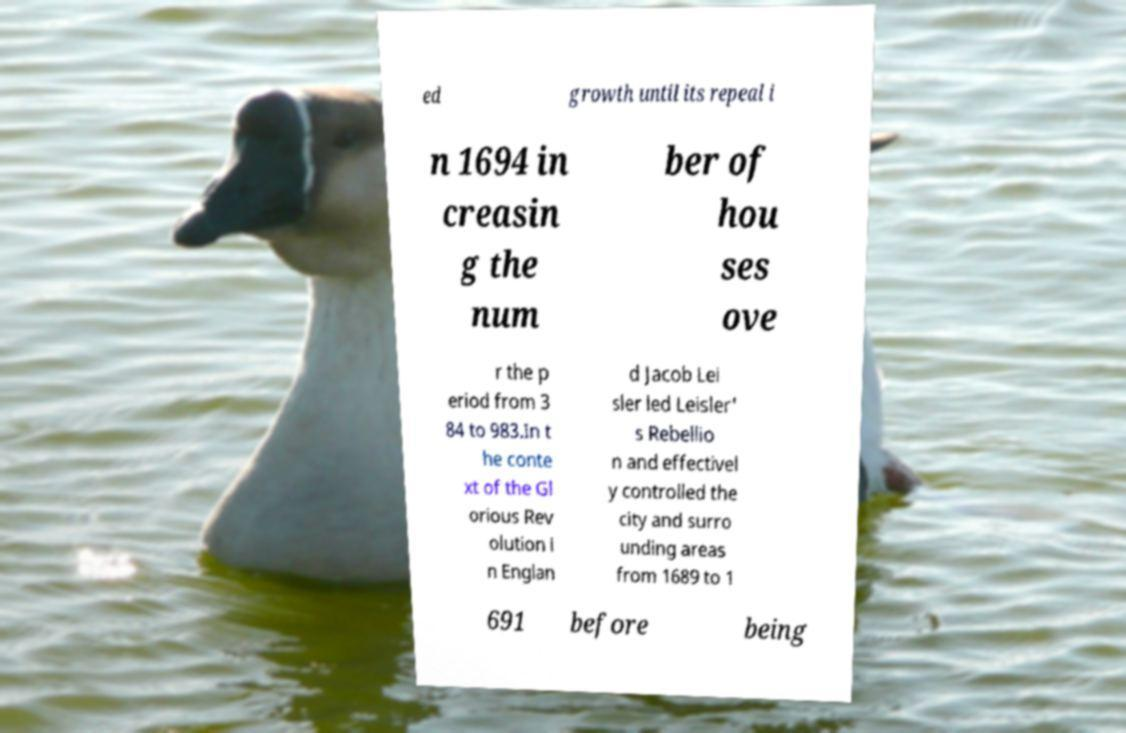For documentation purposes, I need the text within this image transcribed. Could you provide that? ed growth until its repeal i n 1694 in creasin g the num ber of hou ses ove r the p eriod from 3 84 to 983.In t he conte xt of the Gl orious Rev olution i n Englan d Jacob Lei sler led Leisler' s Rebellio n and effectivel y controlled the city and surro unding areas from 1689 to 1 691 before being 